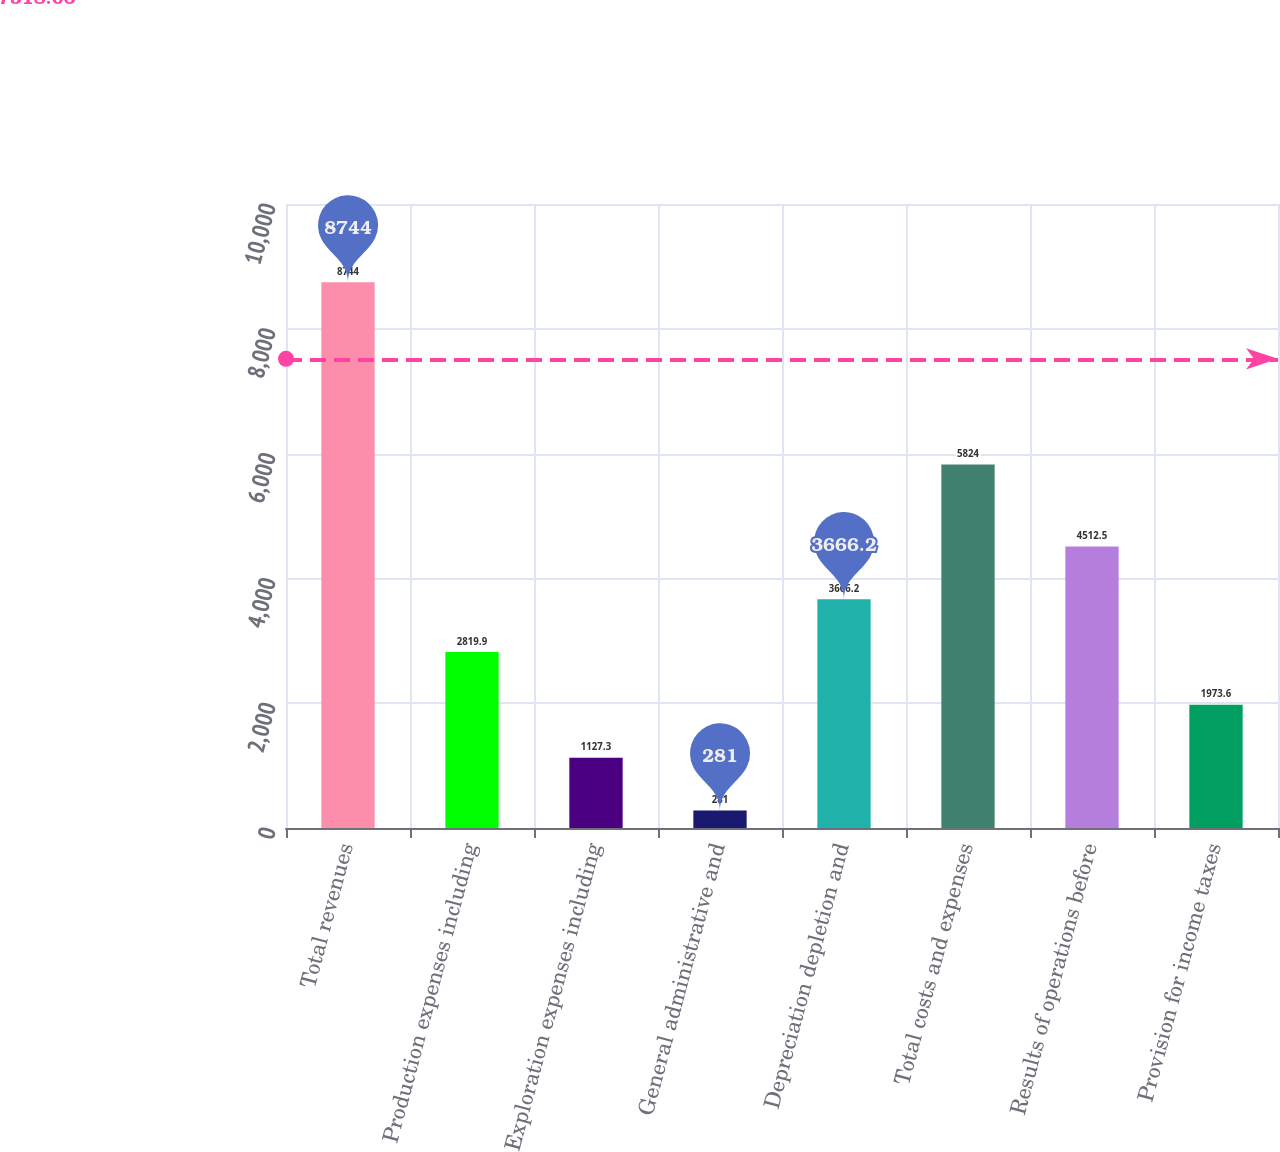Convert chart to OTSL. <chart><loc_0><loc_0><loc_500><loc_500><bar_chart><fcel>Total revenues<fcel>Production expenses including<fcel>Exploration expenses including<fcel>General administrative and<fcel>Depreciation depletion and<fcel>Total costs and expenses<fcel>Results of operations before<fcel>Provision for income taxes<nl><fcel>8744<fcel>2819.9<fcel>1127.3<fcel>281<fcel>3666.2<fcel>5824<fcel>4512.5<fcel>1973.6<nl></chart> 